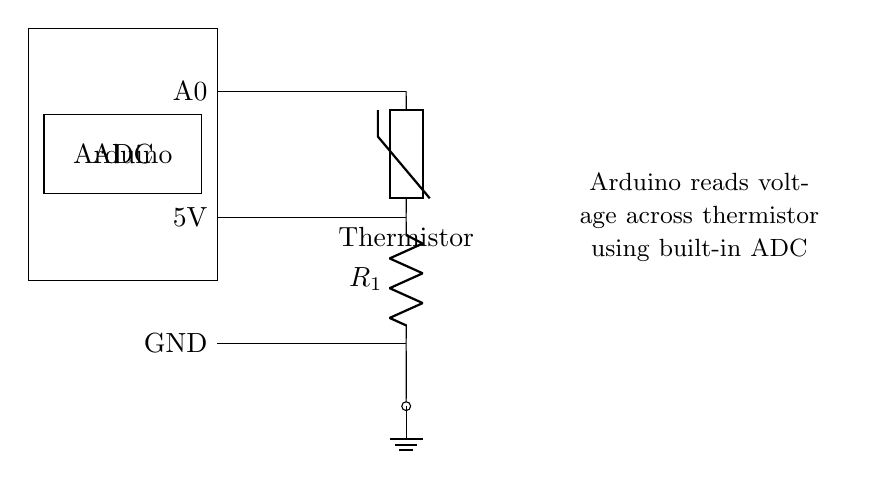What component measures temperature in this circuit? The component that measures temperature is the thermistor. It is placed in the circuit and is indicated in the diagram.
Answer: thermistor What is connected to the analog input A0 on the Arduino? The thermistor is connected to A0. This connection allows the Arduino to read the voltage across the thermistor, which corresponds to its resistance and, consequently, the temperature.
Answer: thermistor What is the supply voltage for this circuit? The supply voltage is 5 volts, shown in the circuit diagram indicating where the voltage is supplied to the thermistor.
Answer: 5 volts What is the function of the resistor labeled R1? The resistor R1 is used in conjunction with the thermistor to form a voltage divider. This setup allows the Arduino to measure the voltage drop across the thermistor, helping to determine its resistance and the temperature.
Answer: voltage divider What type of device is represented by the rectangle on the left? The rectangle on the left represents the Arduino, which is the microcontroller used to process the signals from the thermistor and perform the necessary calculations to determine temperature values.
Answer: Arduino What is the purpose of the ADC in the circuit? The ADC (Analog-to-Digital Converter) converts the analog voltage from the thermistor into a digital value that the Arduino can read and process. This conversion is crucial for interpreting the temperature data that the thermistor provides.
Answer: converts voltage How does the Arduino determine the temperature from the circuit configuration? The Arduino determines the temperature by measuring the voltage across the thermistor using the built-in ADC. The resistance of the thermistor changes with temperature, and the corresponding voltage drop is calculated using the voltage divider formula. This measured voltage is then converted into a digital value and translated into a temperature reading.
Answer: voltage measurement 